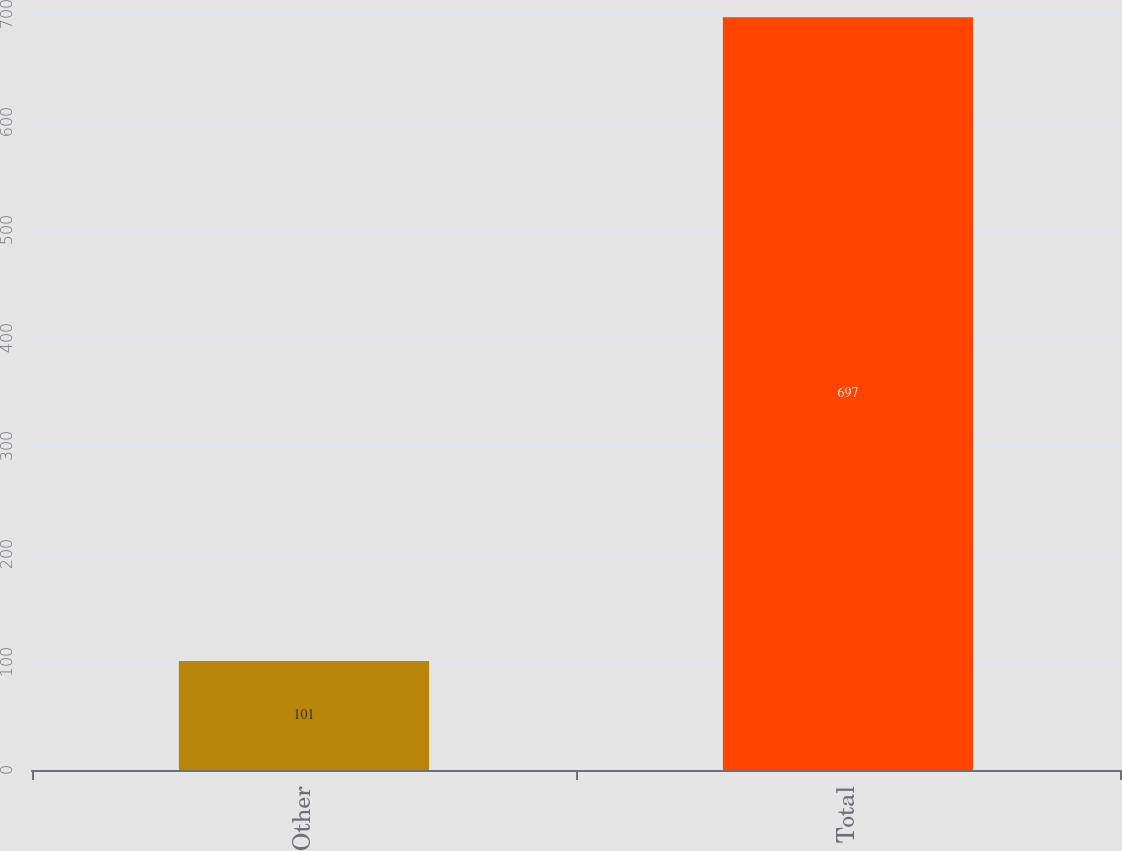Convert chart. <chart><loc_0><loc_0><loc_500><loc_500><bar_chart><fcel>Other<fcel>Total<nl><fcel>101<fcel>697<nl></chart> 